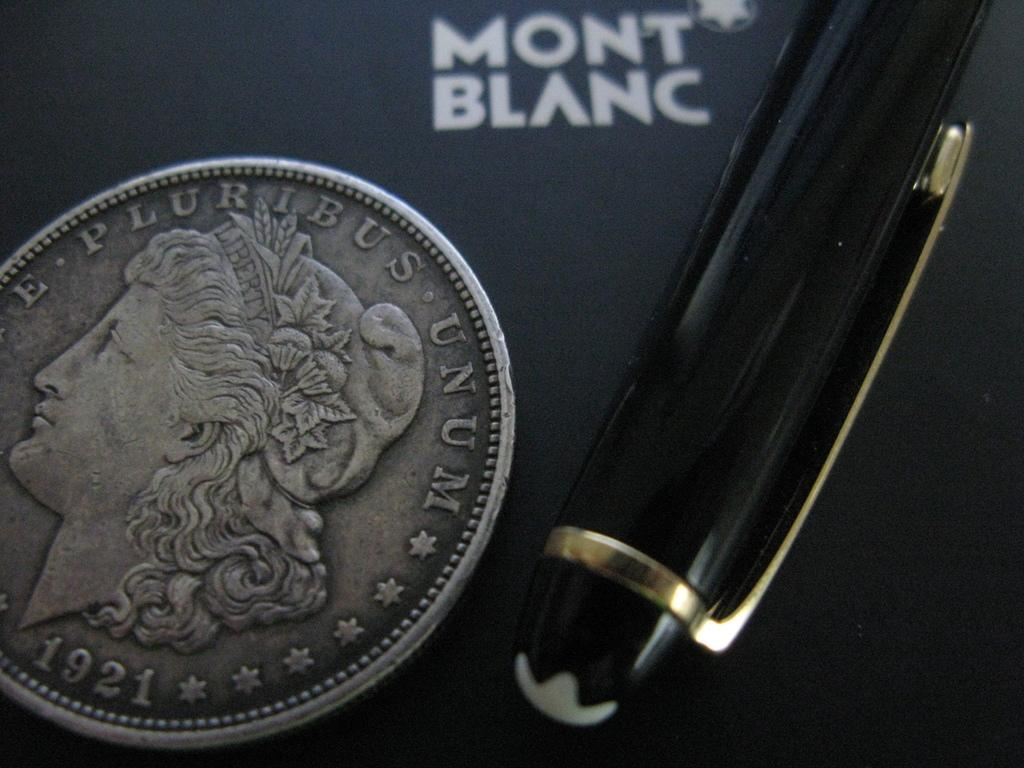<image>
Describe the image concisely. a Mont Blanc Pen top displayed next to a 1921 silver coin 